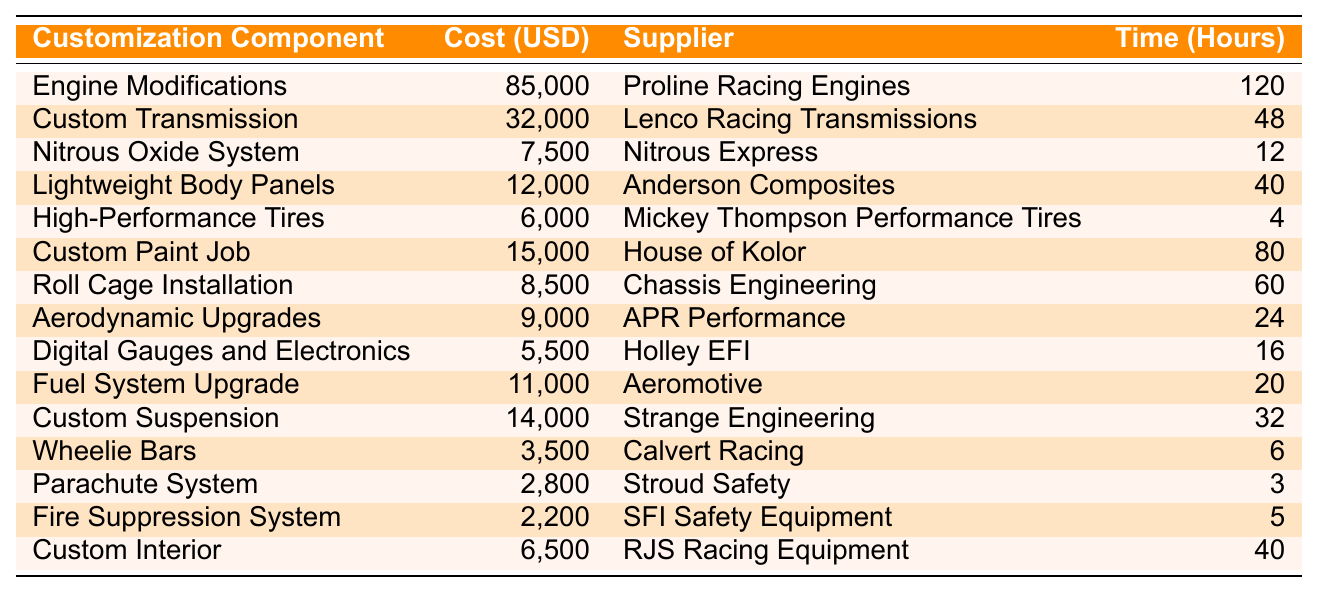What is the total cost for Engine Modifications? The cost for Engine Modifications is listed as 85,000 USD in the table.
Answer: 85,000 Which supplier provides the Custom Transmission? The supplier for the Custom Transmission is Lenco Racing Transmissions, as per the table.
Answer: Lenco Racing Transmissions How much do High-Performance Tires cost? The cost for High-Performance Tires is listed as 6,000 USD in the table.
Answer: 6,000 What is the average installation time for all customization components? To find the average installation time, sum all the hours (120 + 48 + 12 + 40 + 4 + 80 + 60 + 24 + 16 + 20 + 32 + 6 + 3 + 5 + 40 =  476) and divide by the number of components (15), which gives an average of 31.73 hours.
Answer: Approximately 31.73 Is the cost of a Parachute System less than 3,000 USD? The cost for a Parachute System is 2,800 USD, which is indeed less than 3,000 USD.
Answer: Yes Which customization component has the highest cost? By examining the costs, Engine Modifications are the highest at 85,000 USD.
Answer: Engine Modifications How much do the top three most expensive components cost in total? Adding the costs of the top three components: Engine Modifications (85,000) + Custom Transmission (32,000) + Custom Paint Job (15,000) gives a total of 132,000 USD.
Answer: 132,000 Which supplier has the cheapest installation time? To determine the cheapest installation time, we look at the installation hours. The Parachute System has the least at 3 hours.
Answer: Parachute System What is the total cost of all customization components combined? Summing all costs: (85,000 + 32,000 + 7,500 + 12,000 + 6,000 + 15,000 + 8,500 + 9,000 + 5,500 + 11,000 + 14,000 + 3,500 + 2,800 + 2,200 + 6,500 =  304,000 USD).
Answer: 304,000 How does the cost of the Fire Suppression System compare to the average cost of the components? The Fire Suppression System costs 2,200 USD. The average cost is 20,267 USD (304,000 total cost / 15 components). Since 2,200 is less than 20,267, it costs less than average.
Answer: Less than average 